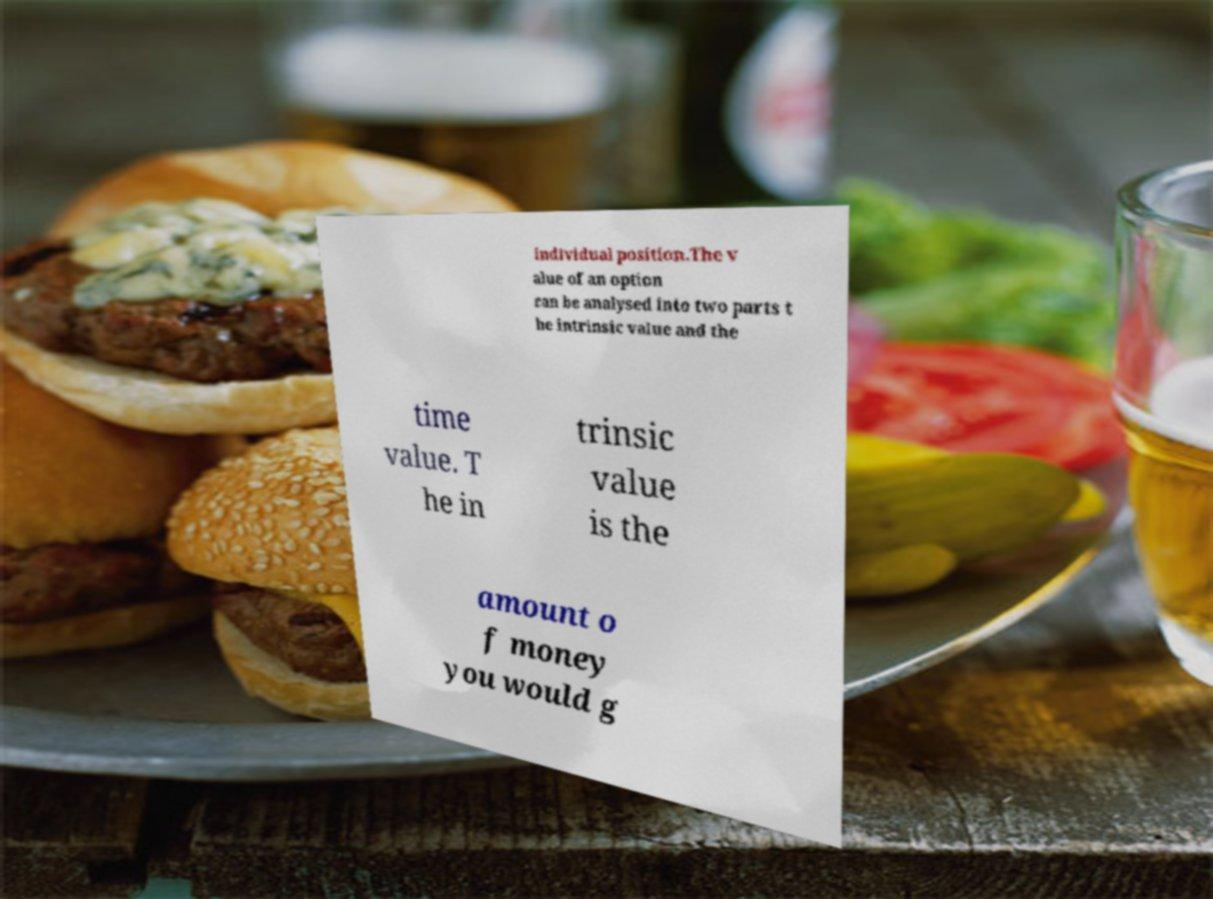What messages or text are displayed in this image? I need them in a readable, typed format. individual position.The v alue of an option can be analysed into two parts t he intrinsic value and the time value. T he in trinsic value is the amount o f money you would g 